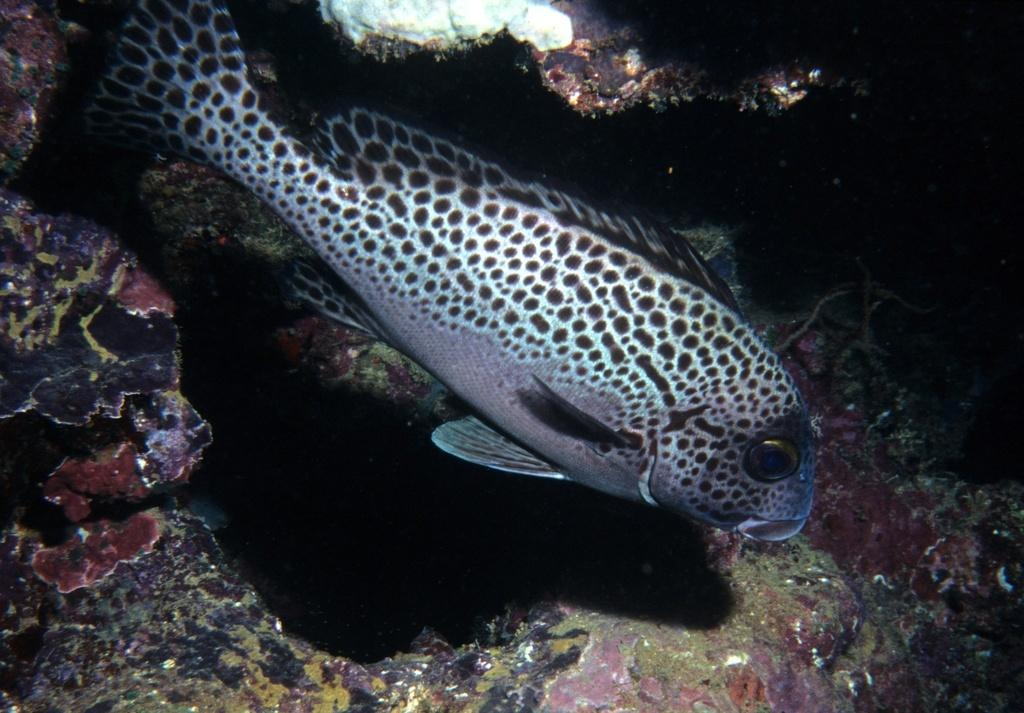What type of animals can be seen in the image? There are fish in the image. What other objects can be seen in the image? There are stones in the image. What type of rail system is present in the image? There is no rail system present in the image; it only features fish and stones. How many snakes can be seen in the image? There are no snakes present in the image; it only features fish and stones. 